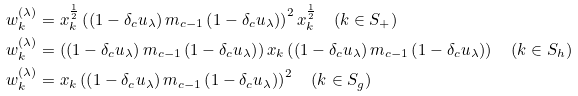Convert formula to latex. <formula><loc_0><loc_0><loc_500><loc_500>w _ { k } ^ { ( \lambda ) } & = x _ { k } ^ { \frac { 1 } { 2 } } \left ( \left ( 1 - \delta _ { c } u _ { \lambda } \right ) m _ { c - 1 } \left ( 1 - \delta _ { c } u _ { \lambda } \right ) \right ) ^ { 2 } x _ { k } ^ { \frac { 1 } { 2 } } \quad ( k \in S _ { + } ) \\ w _ { k } ^ { ( \lambda ) } & = \left ( \left ( 1 - \delta _ { c } u _ { \lambda } \right ) m _ { c - 1 } \left ( 1 - \delta _ { c } u _ { \lambda } \right ) \right ) x _ { k } \left ( \left ( 1 - \delta _ { c } u _ { \lambda } \right ) m _ { c - 1 } \left ( 1 - \delta _ { c } u _ { \lambda } \right ) \right ) \quad ( k \in S _ { h } ) \\ w _ { k } ^ { ( \lambda ) } & = x _ { k } \left ( \left ( 1 - \delta _ { c } u _ { \lambda } \right ) m _ { c - 1 } \left ( 1 - \delta _ { c } u _ { \lambda } \right ) \right ) ^ { 2 } \quad ( k \in S _ { g } )</formula> 